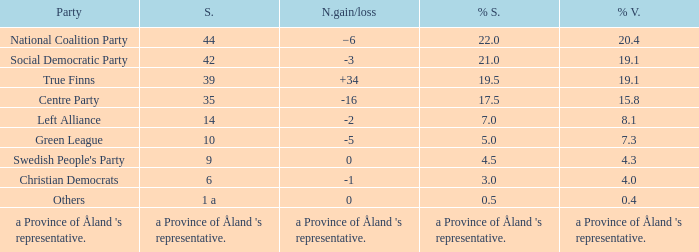Which party has a net gain/loss of -2? Left Alliance. 